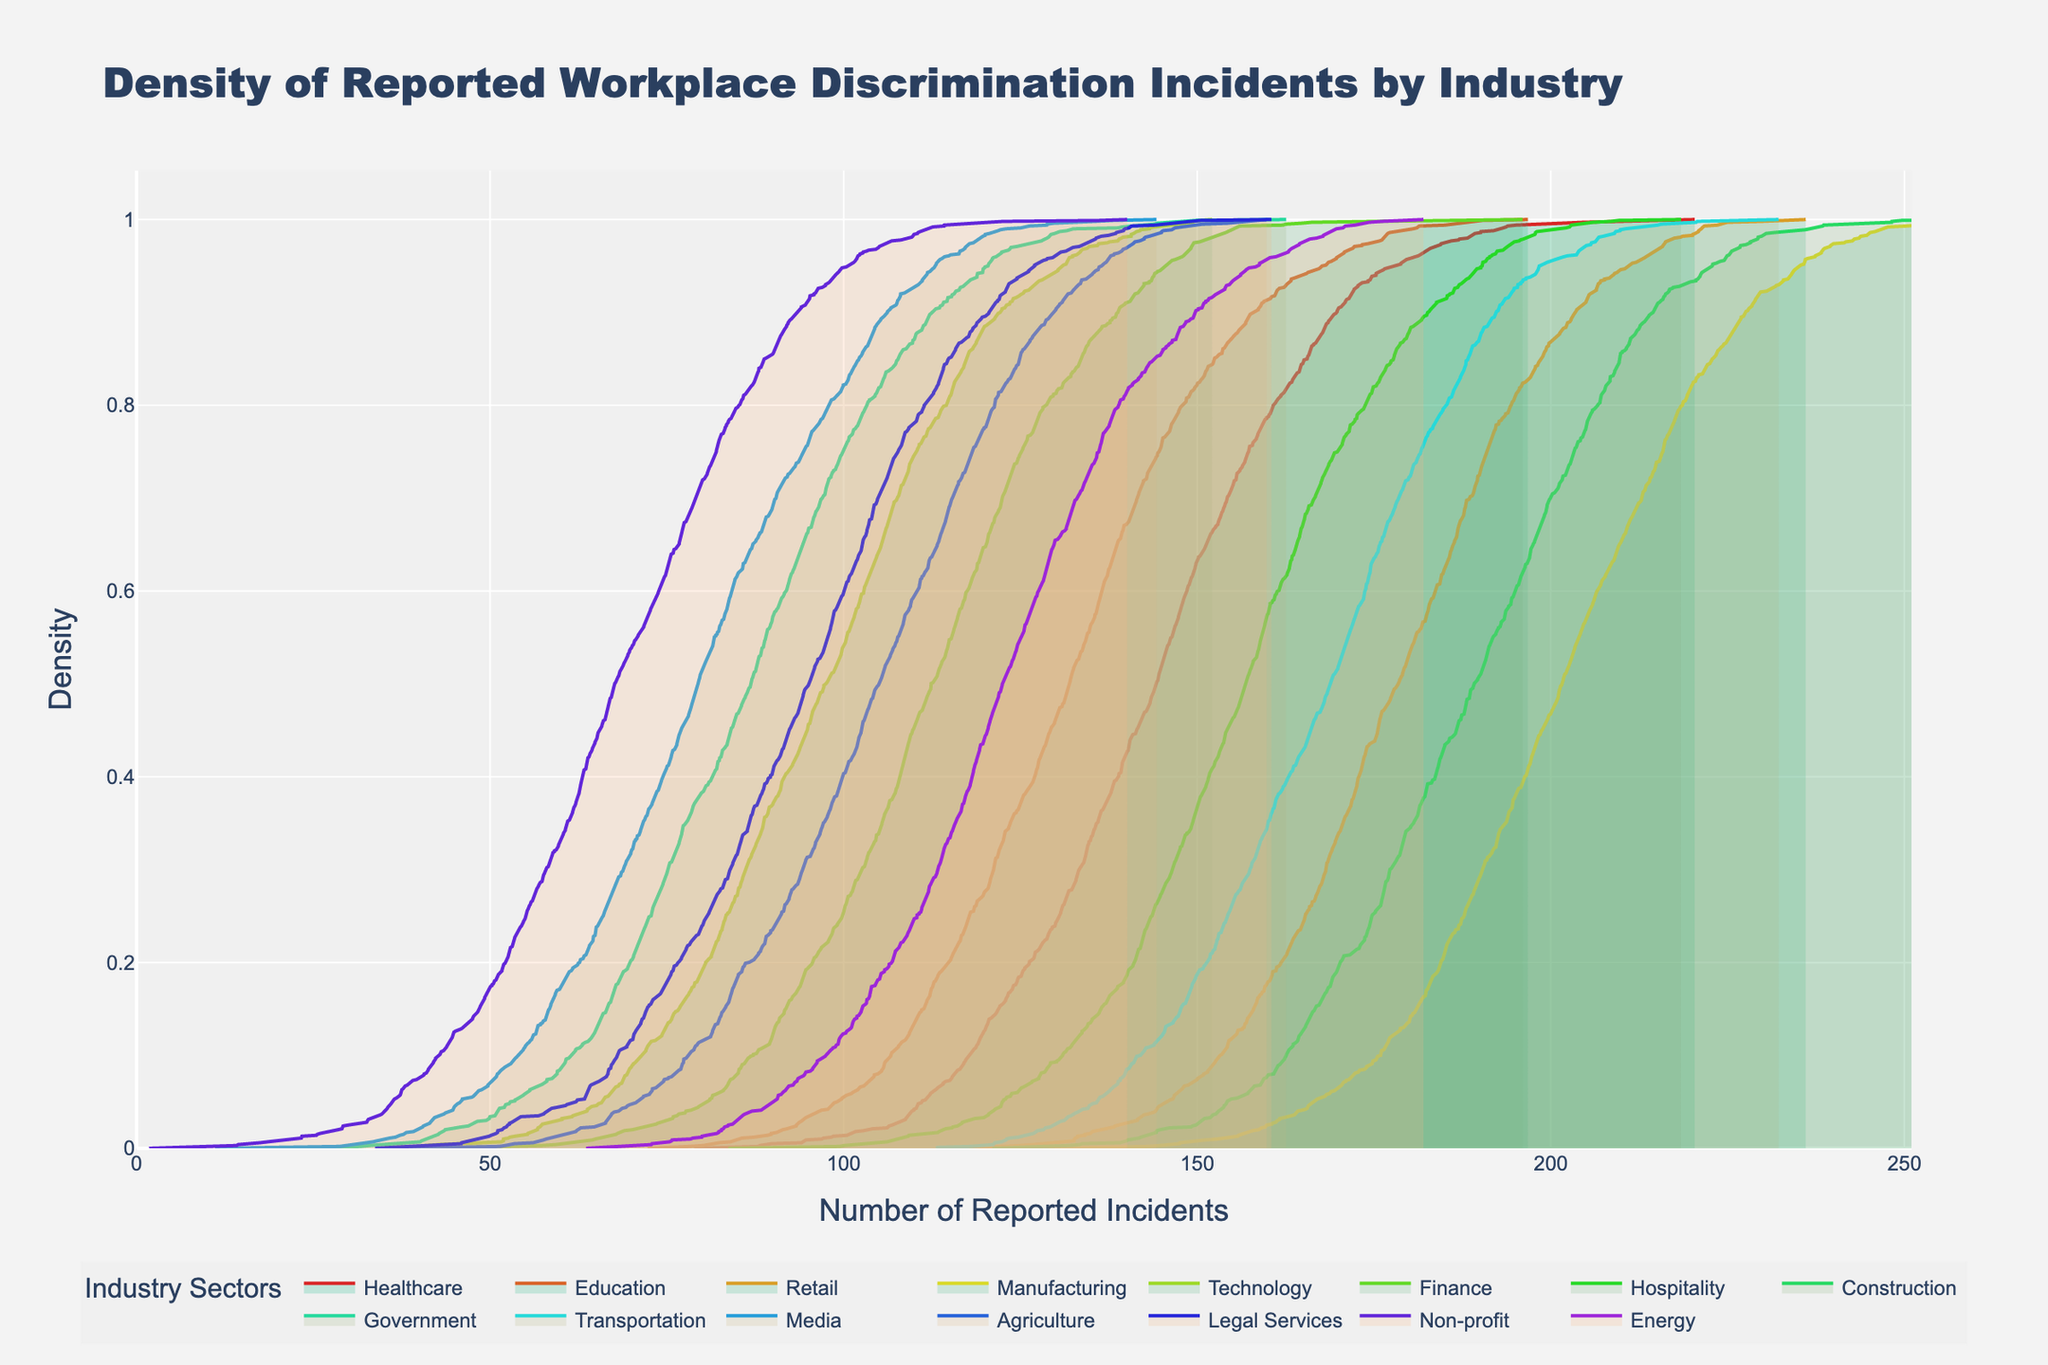what is the x-axis label in the density plot? The x-axis label is given in the plot, which tells us what the density plot measures horizontally. By reading the label, we can understand what the horizontal dimension represents.
Answer: Number of Reported Incidents What's the highest point of density for the Healthcare sector? To find the highest point of density for the Healthcare sector, we need to look at the peak of the density curve corresponding to Healthcare. The y-axis denotes density, so the maximum y-value on this curve represents the highest point of density.
Answer: Around 145 incidents Which industry has the highest number of reported incidents? By examining the rightmost extent of the density curves in the plot, we can determine which industry has the highest number of reported incidents.
Answer: Manufacturing How do the density curves for the Transportation and Hospitality sectors compare? To compare the density curves for Transportation and Hospitality, we need to look at where each curve peaks and their overlap. The curve peaking higher and more concentrated indicates a higher density of incidents around certain values.
Answer: Transportation peaks higher and is slightly more spread out compared to Hospitality What range of reported incidents does the Government sector cover? Checking the density curve for the Government sector, which is identified by its label, we can see the span of its x-axis values from where the curve starts to where it ends.
Answer: About 60 to 110 incidents Does the Technology sector have fewer reported incidents compared to Retail? By comparing the density plots for Technology and Retail, we must look at the general location of the peaks and the spread of the curves along the x-axis.
Answer: Yes Which industry shows the broadest spread in reported incidents? To determine which industry has the broadest spread in reported incidents, examine the extent of the x-axis covered by each density curve. The industry with the widest x-axis span has the broadest spread.
Answer: Manufacturing How does the density of reported incidents in the Non-profit sector differ from that in the Energy sector? To find the difference in density between Non-profit and Energy sectors, we should compare the peaks and the spread of their density curves.
Answer: Non-profit has a lower peak and less spread compared to Energy What is the primary takeaway from the density plot on workplace discrimination incidents by industry? Given the density plot's title and the visual information, the main takeaway is summarized by looking at which industries have high peaks and wide spreads, indicating more and less frequent occurrences of discrimination incidents.
Answer: Varies significantly by industry Are there any sectors with lower reported incident densities than Construction? To answer this, we should identify and compare density curves of all sectors against Construction's density curve, looking for curves with lower peaks.
Answer: Yes, several sectors (e.g., Government, Non-profit) have lower densities 